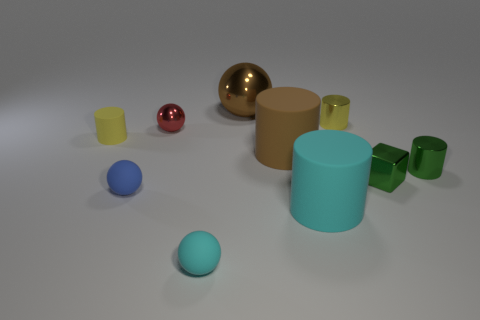Subtract all tiny balls. How many balls are left? 1 Subtract all yellow cylinders. How many cylinders are left? 3 Subtract all gray spheres. Subtract all brown cylinders. How many spheres are left? 4 Subtract all blocks. How many objects are left? 9 Add 7 small cyan blocks. How many small cyan blocks exist? 7 Subtract 1 green cubes. How many objects are left? 9 Subtract all tiny green metallic objects. Subtract all matte cylinders. How many objects are left? 5 Add 1 green things. How many green things are left? 3 